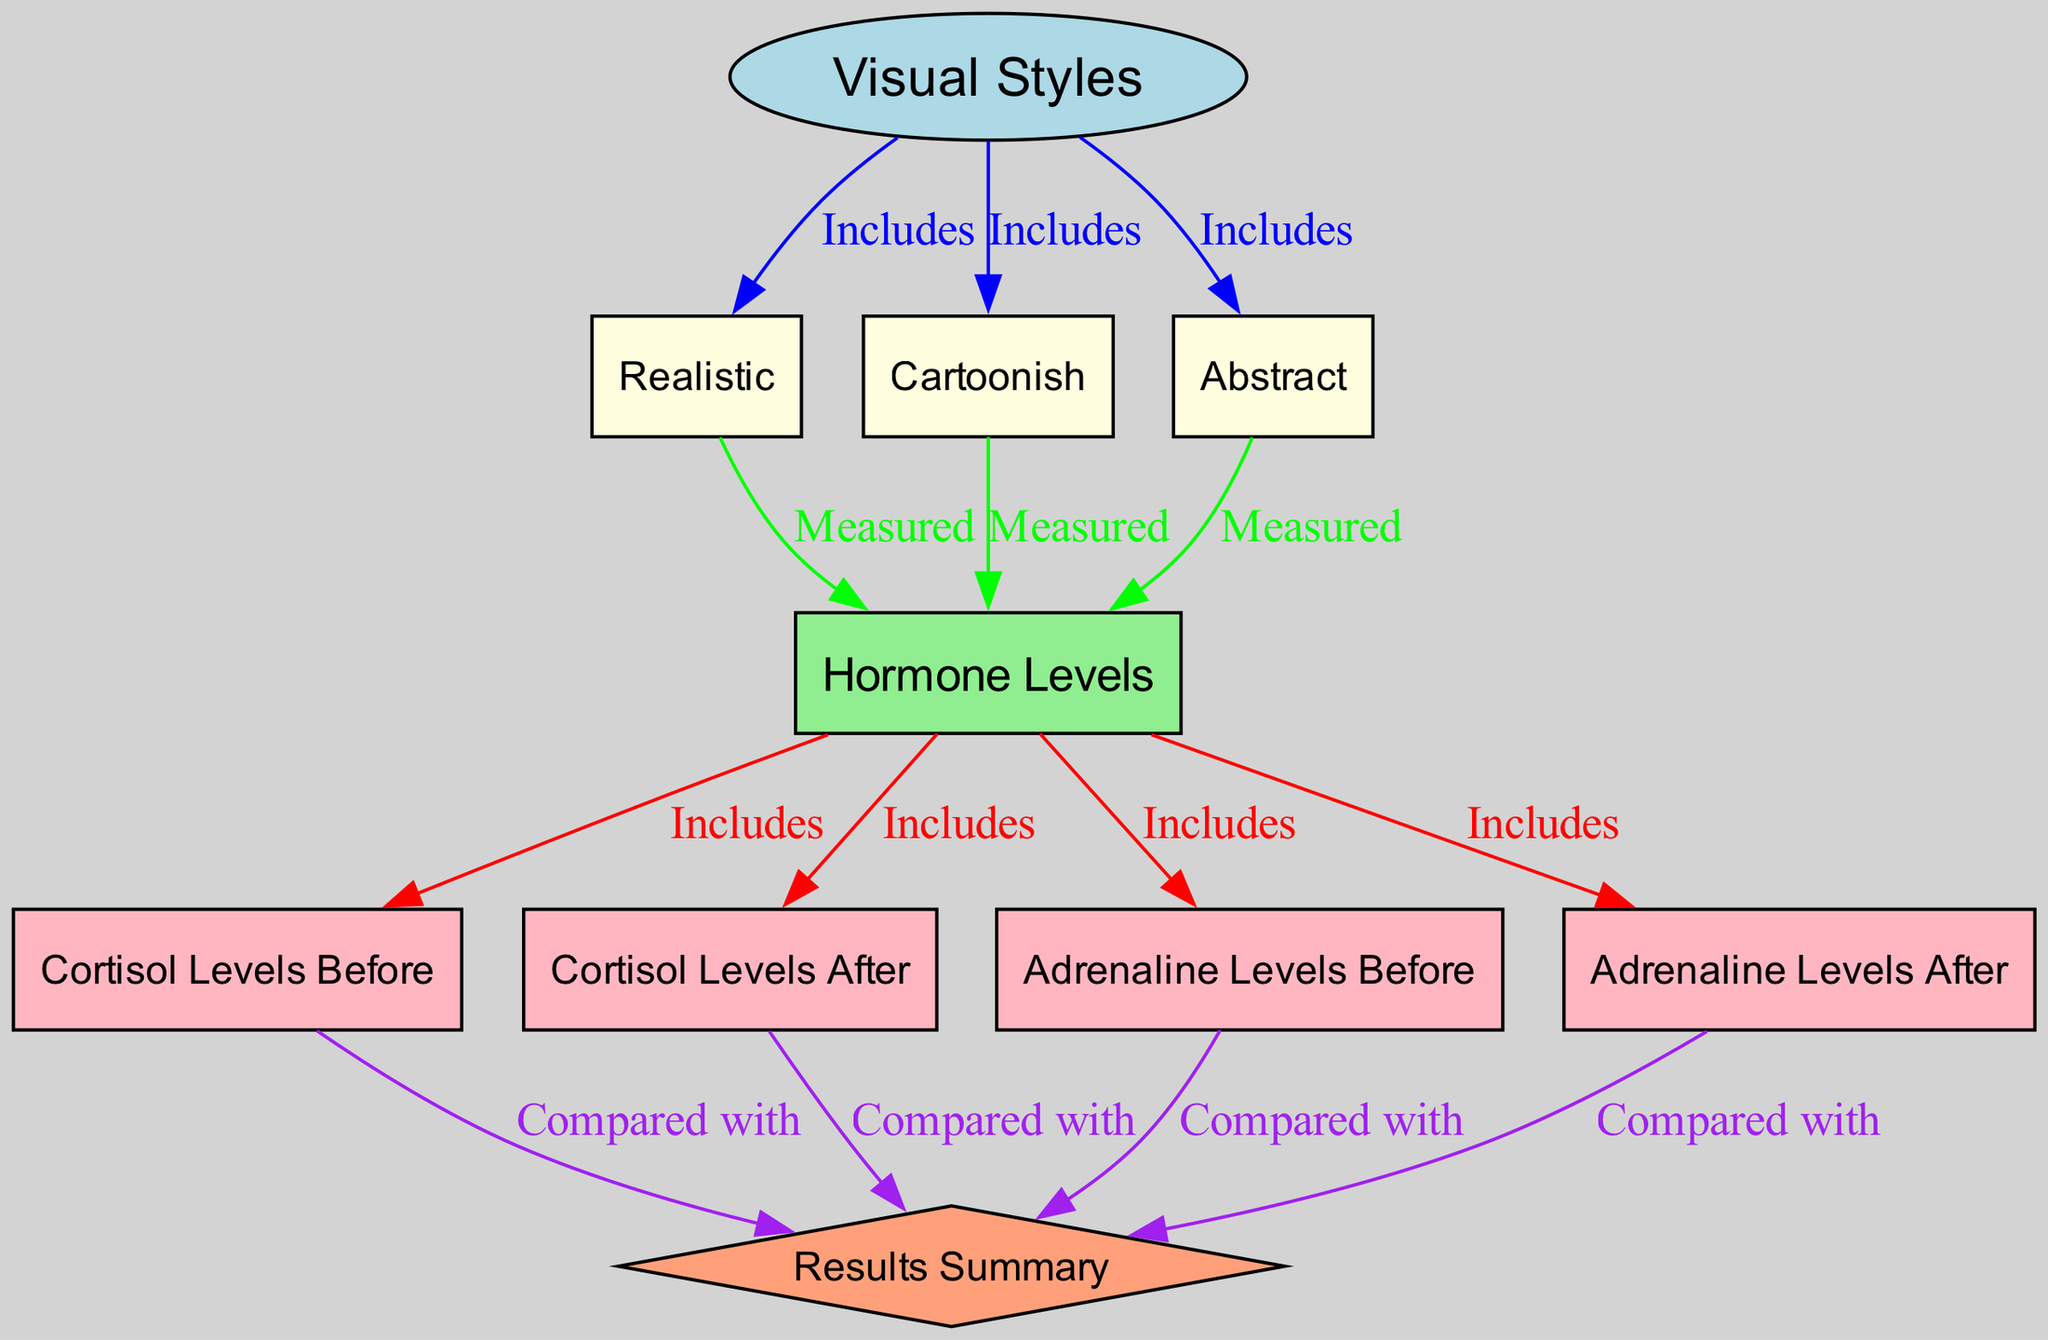What are the three visual styles included in the diagram? The nodes labeled as "Realistic," "Cartoonish," and "Abstract" indicate the visual styles included. They are clearly shown as child nodes of the "Visual Styles" parent node.
Answer: Realistic, Cartoonish, Abstract How many hormone level nodes are present in the diagram? The diagram includes four hormone level nodes: "Cortisol Levels Before," "Cortisol Levels After," "Adrenaline Levels Before," and "Adrenaline Levels After." Therefore, the total is four nodes.
Answer: 4 What is the main focus of the connections labeled "Measured"? The connections labeled "Measured" connect the visual style nodes to the "Hormone Levels" node, indicating that these styles are directly associated with the measurement of stress hormone levels.
Answer: Hormone Levels Which visual style is linked to the most hormone level measurements? Each of the three visual styles (Realistic, Cartoonish, and Abstract) has an equal connection to the "Hormone Levels" node, meaning they all contribute equally to the measurement process.
Answer: Equal connection What does the results summary compare cortisol levels before and after? The "Results Summary" node connects to "Cortisol Levels Before" and "Cortisol Levels After," indicating that the results of the analysis will include a comparison between these two sets of cortisol levels.
Answer: Cortisol Levels Which color represents the hormone levels in the diagram? The hormone levels node is filled with a light green color, which distinguishes it from other categories in the diagram.
Answer: Light green How do the edges colored purple relate to the diagram? The purple edges in the diagram connect the hormone levels (cortisol and adrenaline levels) to the "Results Summary," indicating that these hormone measurements will be summarized and compared.
Answer: Results Summary Which visual style is measured first based on the diagram's flow? The connections from the visual styles to "Hormone Levels" do not indicate a specific order of measurement; thus, there isn't a first measured style indicated in the diagram's flow.
Answer: None indicated What type of hormone level is measured before gameplay? The diagram specifies two types of hormone levels that are assessed before gameplay—Cortisol Levels Before and Adrenaline Levels Before.
Answer: Cortisol Levels Before, Adrenaline Levels Before 